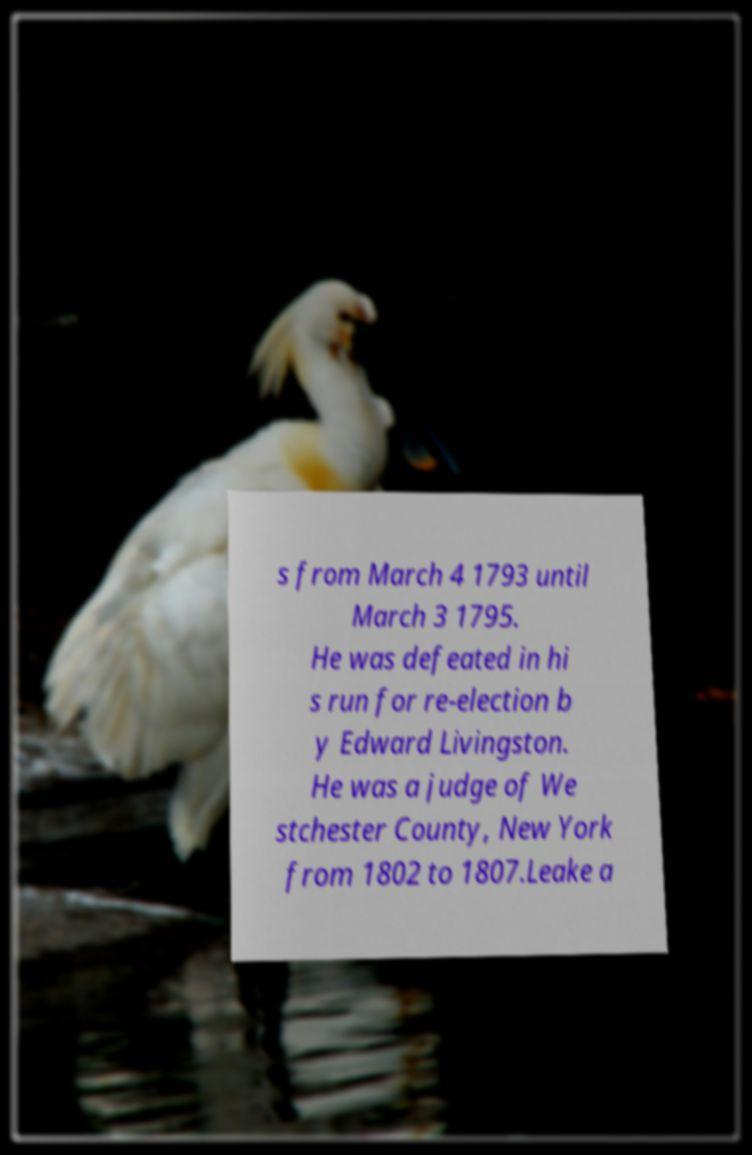Please read and relay the text visible in this image. What does it say? s from March 4 1793 until March 3 1795. He was defeated in hi s run for re-election b y Edward Livingston. He was a judge of We stchester County, New York from 1802 to 1807.Leake a 